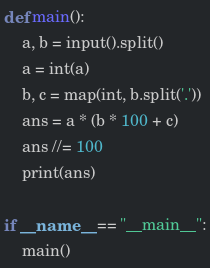Convert code to text. <code><loc_0><loc_0><loc_500><loc_500><_Python_>def main():
    a, b = input().split()
    a = int(a)
    b, c = map(int, b.split('.'))
    ans = a * (b * 100 + c)
    ans //= 100
    print(ans)

if __name__ == "__main__":
    main()</code> 